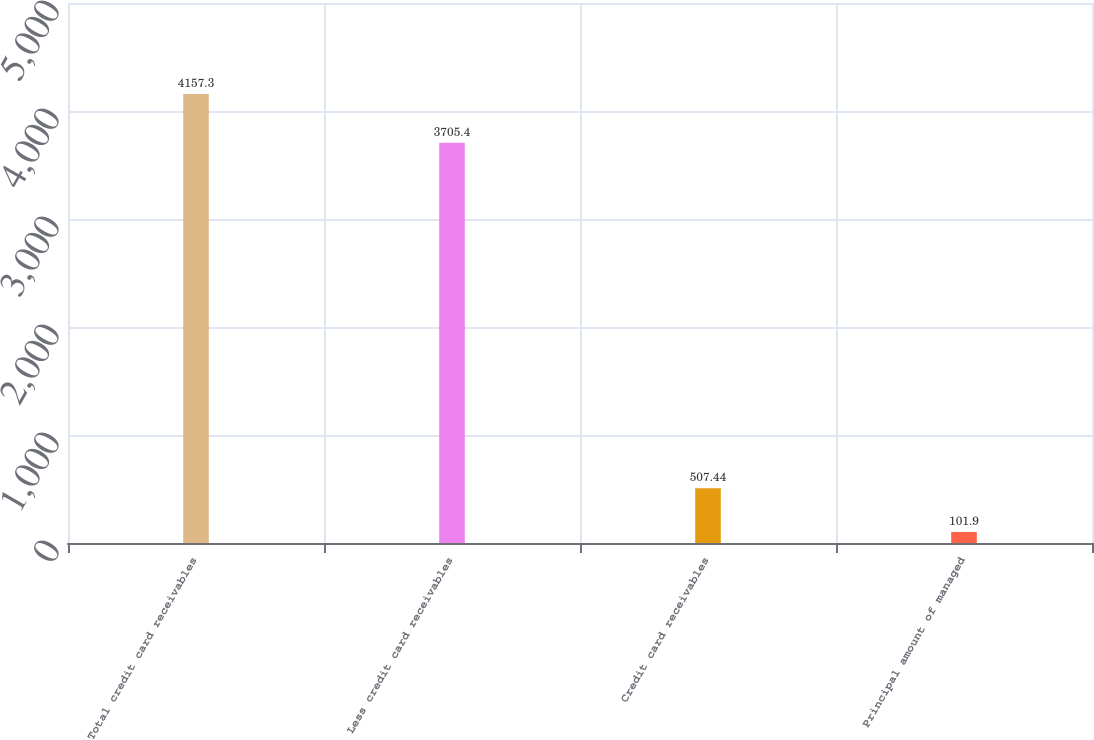Convert chart. <chart><loc_0><loc_0><loc_500><loc_500><bar_chart><fcel>Total credit card receivables<fcel>Less credit card receivables<fcel>Credit card receivables<fcel>Principal amount of managed<nl><fcel>4157.3<fcel>3705.4<fcel>507.44<fcel>101.9<nl></chart> 